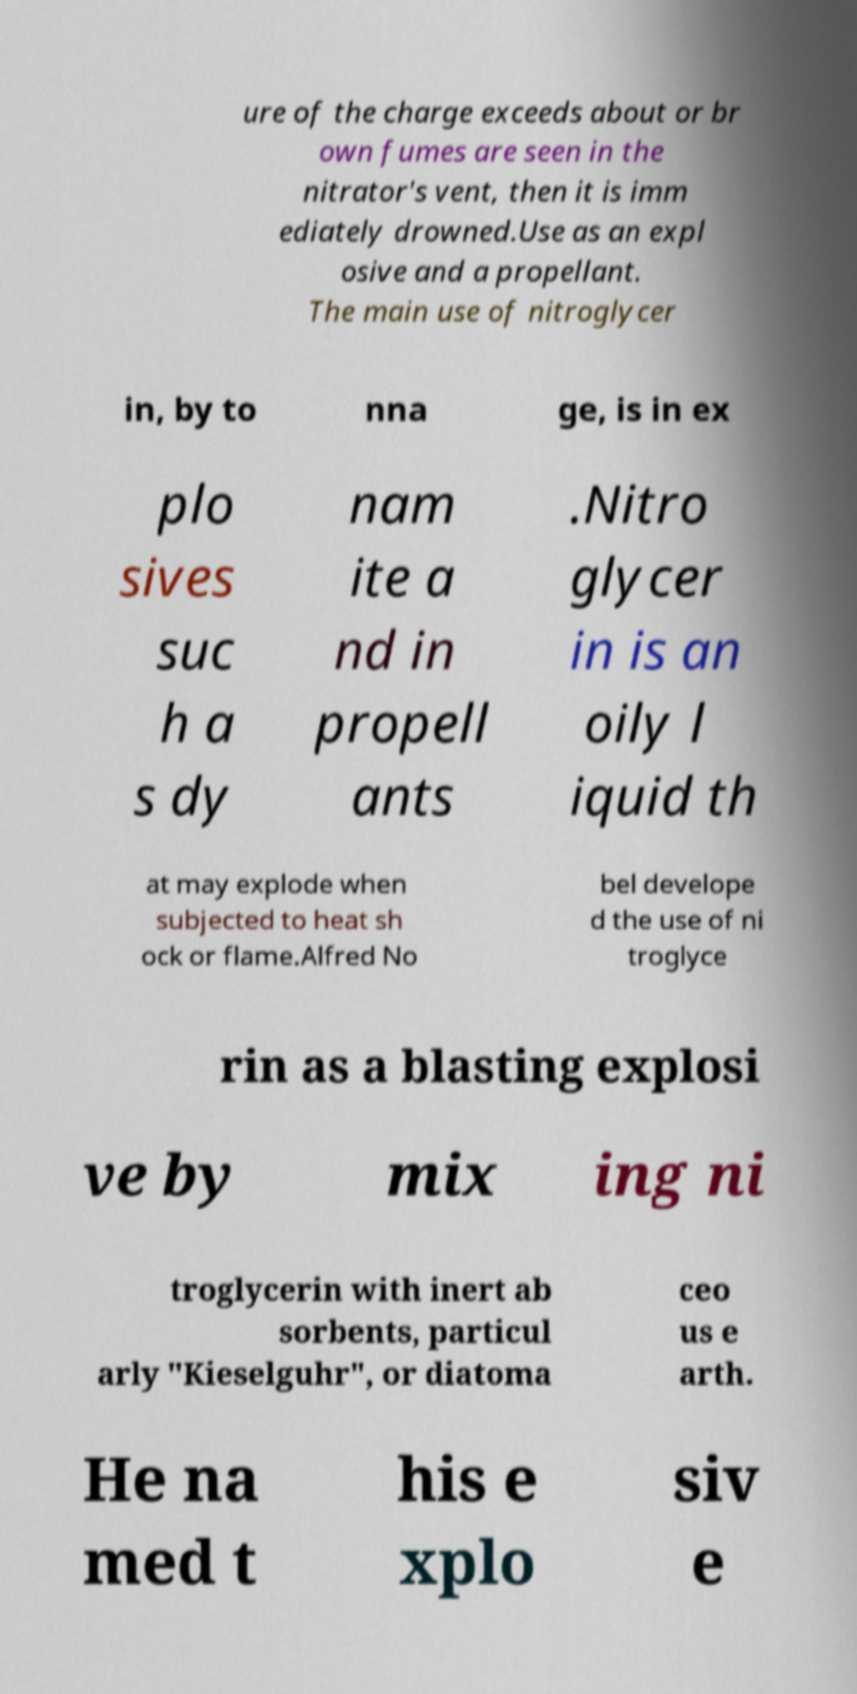For documentation purposes, I need the text within this image transcribed. Could you provide that? ure of the charge exceeds about or br own fumes are seen in the nitrator's vent, then it is imm ediately drowned.Use as an expl osive and a propellant. The main use of nitroglycer in, by to nna ge, is in ex plo sives suc h a s dy nam ite a nd in propell ants .Nitro glycer in is an oily l iquid th at may explode when subjected to heat sh ock or flame.Alfred No bel develope d the use of ni troglyce rin as a blasting explosi ve by mix ing ni troglycerin with inert ab sorbents, particul arly "Kieselguhr", or diatoma ceo us e arth. He na med t his e xplo siv e 